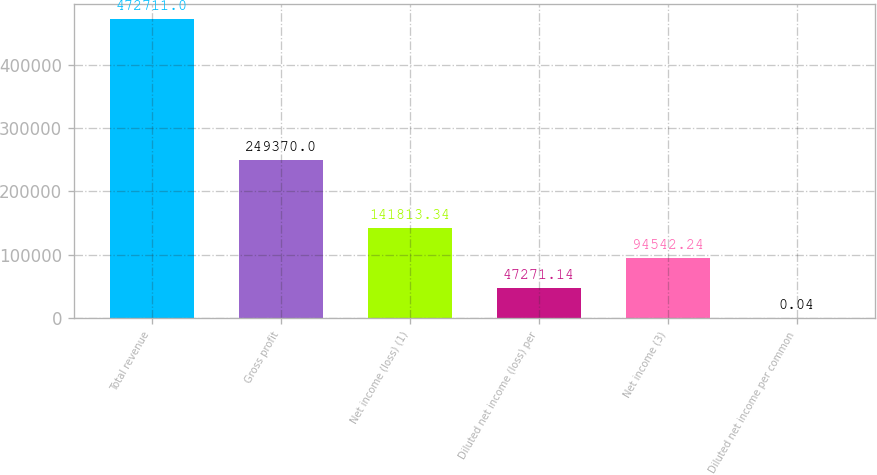<chart> <loc_0><loc_0><loc_500><loc_500><bar_chart><fcel>Total revenue<fcel>Gross profit<fcel>Net income (loss) (1)<fcel>Diluted net income (loss) per<fcel>Net income (3)<fcel>Diluted net income per common<nl><fcel>472711<fcel>249370<fcel>141813<fcel>47271.1<fcel>94542.2<fcel>0.04<nl></chart> 